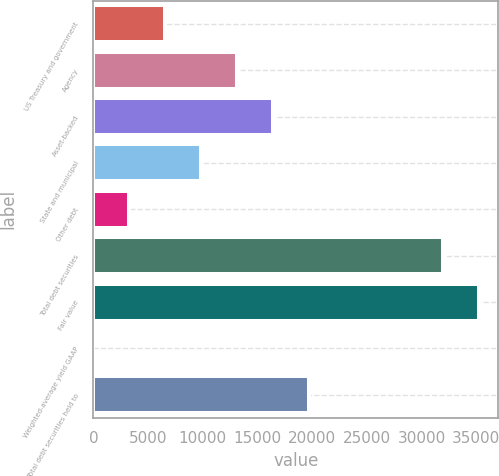Convert chart. <chart><loc_0><loc_0><loc_500><loc_500><bar_chart><fcel>US Treasury and government<fcel>Agency<fcel>Asset-backed<fcel>State and municipal<fcel>Other debt<fcel>Total debt securities<fcel>Fair value<fcel>Weighted-average yield GAAP<fcel>Total debt securities held to<nl><fcel>6567.79<fcel>13132.6<fcel>16415<fcel>9850.19<fcel>3285.39<fcel>31970<fcel>35252.4<fcel>2.99<fcel>19697.4<nl></chart> 